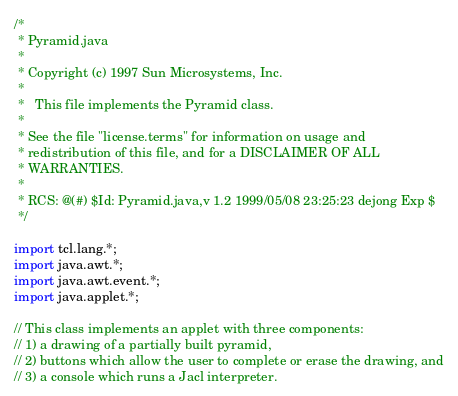<code> <loc_0><loc_0><loc_500><loc_500><_Java_>/*
 * Pyramid.java
 *
 * Copyright (c) 1997 Sun Microsystems, Inc.
 *
 *   This file implements the Pyramid class.
 *
 * See the file "license.terms" for information on usage and
 * redistribution of this file, and for a DISCLAIMER OF ALL
 * WARRANTIES.
 * 
 * RCS: @(#) $Id: Pyramid.java,v 1.2 1999/05/08 23:25:23 dejong Exp $
 */

import tcl.lang.*;
import java.awt.*;
import java.awt.event.*;
import java.applet.*;

// This class implements an applet with three components:
// 1) a drawing of a partially built pyramid,
// 2) buttons which allow the user to complete or erase the drawing, and
// 3) a console which runs a Jacl interpreter.
</code> 